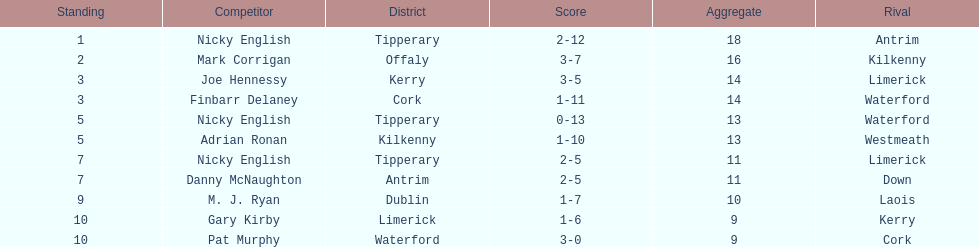Who ranked above mark corrigan? Nicky English. 